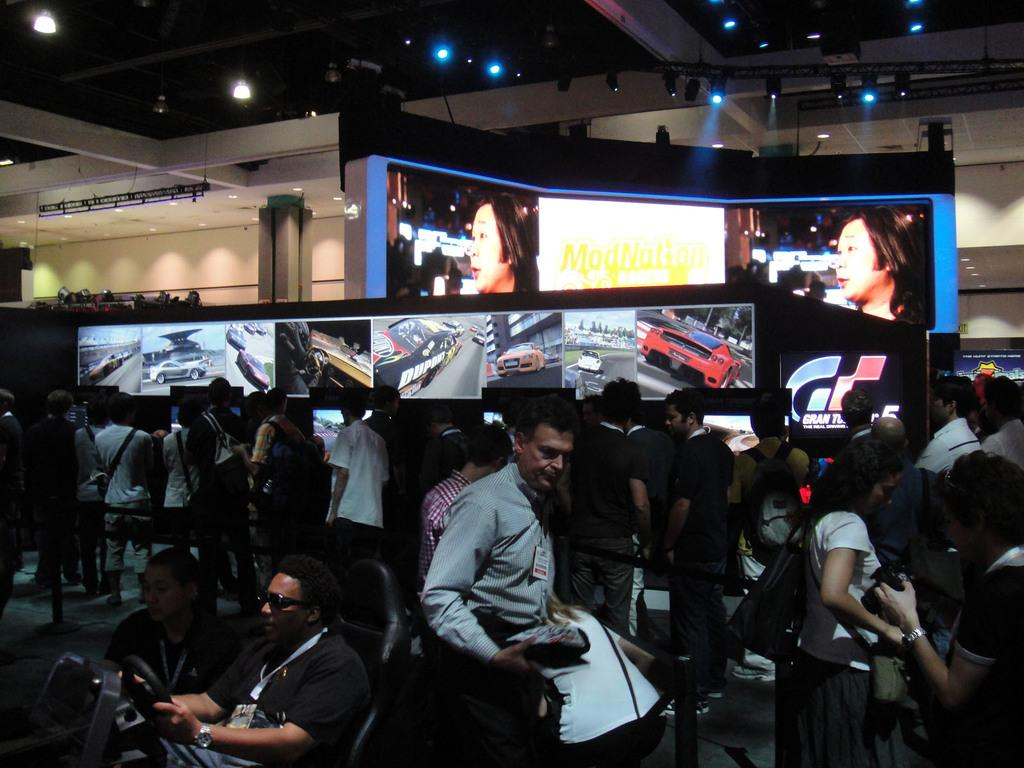How many people are in the image? There are people in the image, but the exact number is not specified. What is one person doing in the image? One person is sitting on a chair and holding a steering wheel. What can be seen in the background of the image? There are lights and screens in the background of the image. What is displayed on the screens? The screens display images of people and cars. What type of tree is growing in the image? There is no tree present in the image. What channel is the person watching on the screens? The screens display images of people and cars, but there is no mention of a specific channel. 